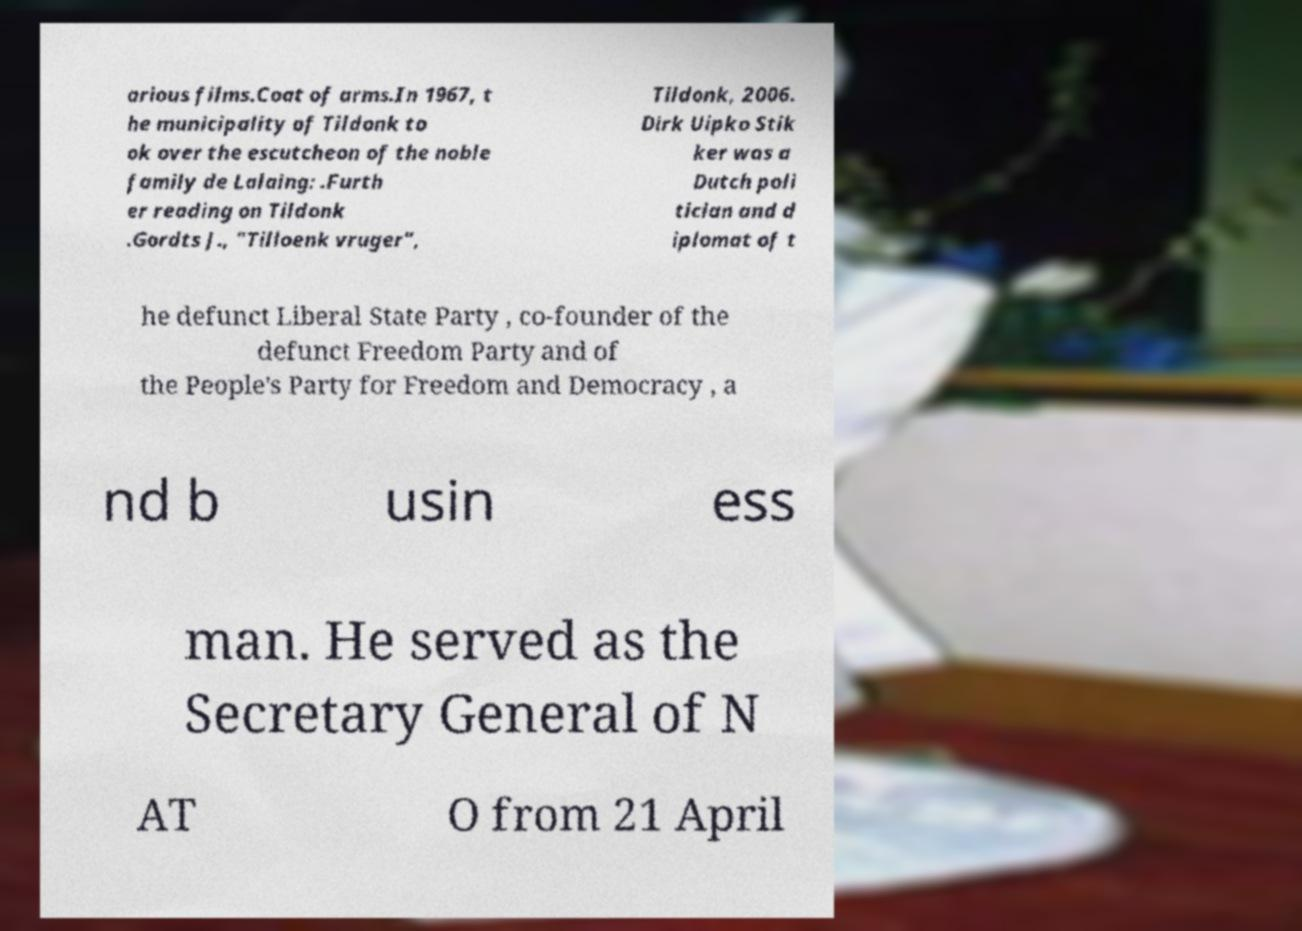Please read and relay the text visible in this image. What does it say? arious films.Coat of arms.In 1967, t he municipality of Tildonk to ok over the escutcheon of the noble family de Lalaing: .Furth er reading on Tildonk .Gordts J., "Tilloenk vruger", Tildonk, 2006. Dirk Uipko Stik ker was a Dutch poli tician and d iplomat of t he defunct Liberal State Party , co-founder of the defunct Freedom Party and of the People's Party for Freedom and Democracy , a nd b usin ess man. He served as the Secretary General of N AT O from 21 April 